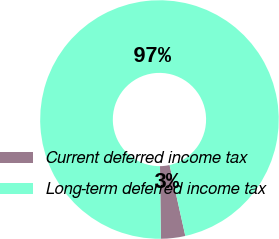Convert chart. <chart><loc_0><loc_0><loc_500><loc_500><pie_chart><fcel>Current deferred income tax<fcel>Long-term deferred income tax<nl><fcel>3.3%<fcel>96.7%<nl></chart> 